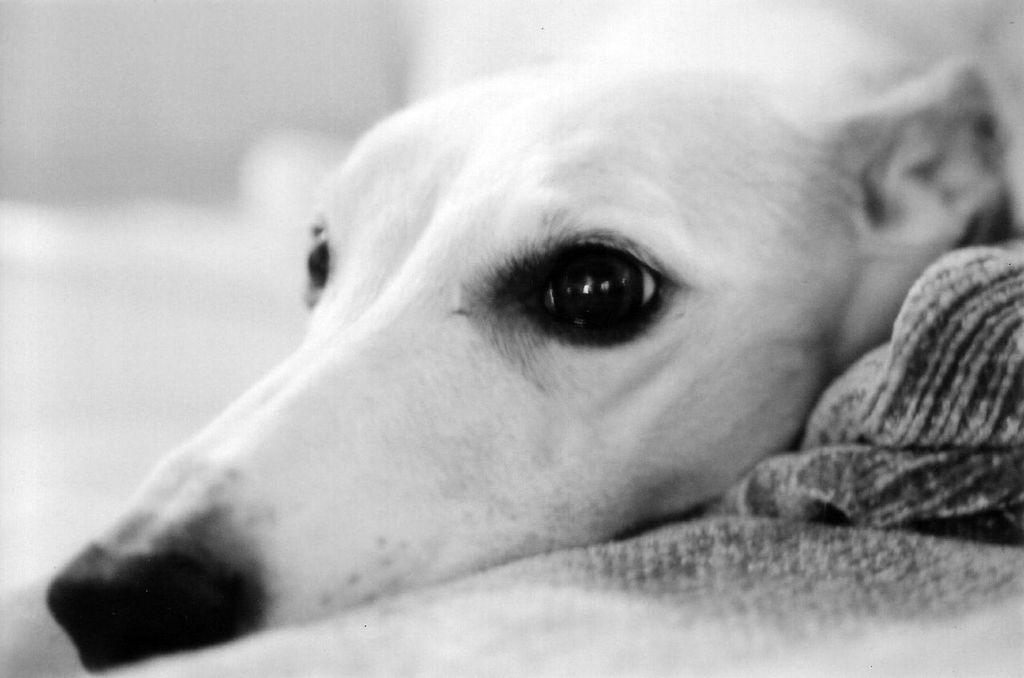What is the main subject of the image? The main subject of the image is a dog face. What color is the dog face? The dog face is white in color. Can you see any lakes in the image? There is no lake present in the image; it features a white dog face. What type of pest is depicted in the image? There is no pest depicted in the image; it features a white dog face. 